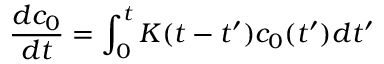Convert formula to latex. <formula><loc_0><loc_0><loc_500><loc_500>\frac { d c _ { 0 } } { d t } = \int _ { 0 } ^ { t } K ( t - t ^ { \prime } ) c _ { 0 } ( t ^ { \prime } ) d t ^ { \prime }</formula> 